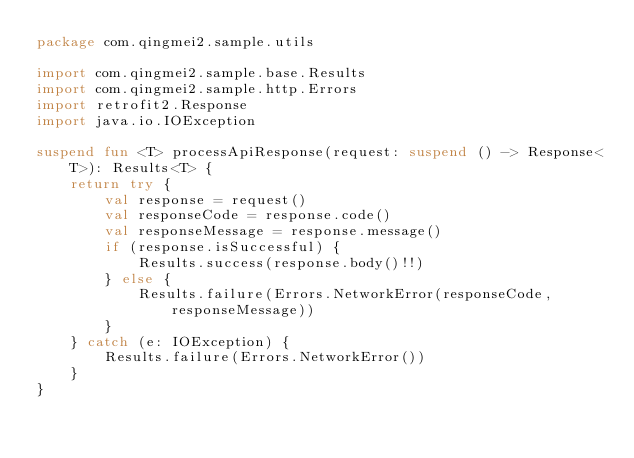<code> <loc_0><loc_0><loc_500><loc_500><_Kotlin_>package com.qingmei2.sample.utils

import com.qingmei2.sample.base.Results
import com.qingmei2.sample.http.Errors
import retrofit2.Response
import java.io.IOException

suspend fun <T> processApiResponse(request: suspend () -> Response<T>): Results<T> {
    return try {
        val response = request()
        val responseCode = response.code()
        val responseMessage = response.message()
        if (response.isSuccessful) {
            Results.success(response.body()!!)
        } else {
            Results.failure(Errors.NetworkError(responseCode, responseMessage))
        }
    } catch (e: IOException) {
        Results.failure(Errors.NetworkError())
    }
}</code> 